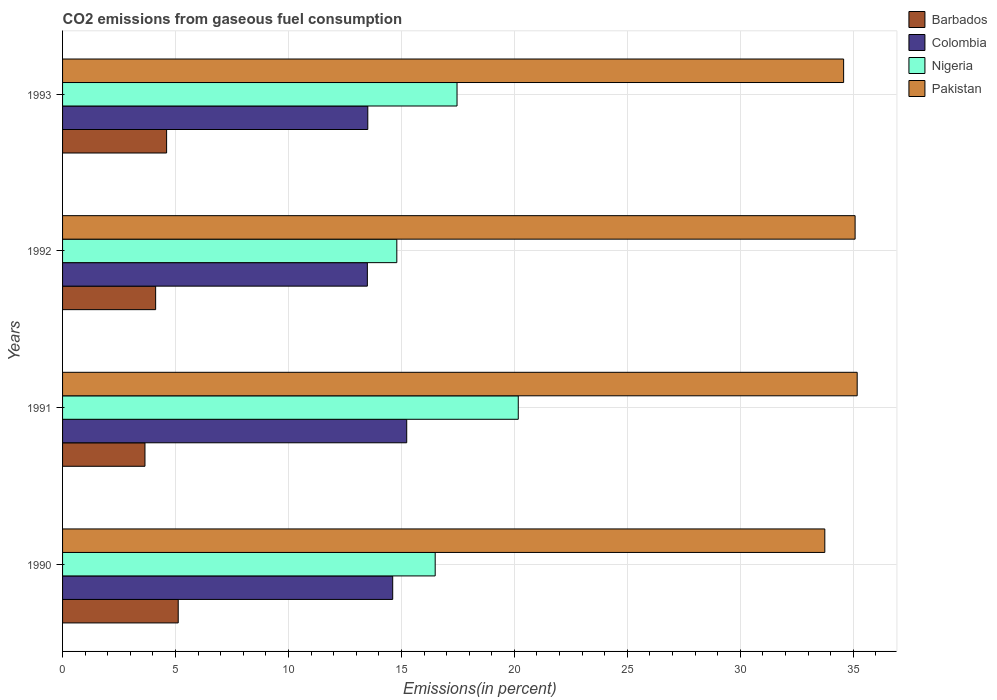How many groups of bars are there?
Your answer should be very brief. 4. What is the label of the 2nd group of bars from the top?
Offer a very short reply. 1992. In how many cases, is the number of bars for a given year not equal to the number of legend labels?
Ensure brevity in your answer.  0. What is the total CO2 emitted in Nigeria in 1992?
Your response must be concise. 14.8. Across all years, what is the maximum total CO2 emitted in Barbados?
Your answer should be very brief. 5.12. Across all years, what is the minimum total CO2 emitted in Pakistan?
Your answer should be compact. 33.74. In which year was the total CO2 emitted in Colombia maximum?
Your answer should be very brief. 1991. In which year was the total CO2 emitted in Barbados minimum?
Provide a short and direct response. 1991. What is the total total CO2 emitted in Colombia in the graph?
Offer a very short reply. 56.85. What is the difference between the total CO2 emitted in Colombia in 1990 and that in 1993?
Your response must be concise. 1.1. What is the difference between the total CO2 emitted in Pakistan in 1993 and the total CO2 emitted in Barbados in 1992?
Your answer should be compact. 30.45. What is the average total CO2 emitted in Barbados per year?
Your answer should be very brief. 4.37. In the year 1992, what is the difference between the total CO2 emitted in Colombia and total CO2 emitted in Pakistan?
Give a very brief answer. -21.59. In how many years, is the total CO2 emitted in Pakistan greater than 28 %?
Provide a succinct answer. 4. What is the ratio of the total CO2 emitted in Colombia in 1990 to that in 1992?
Your answer should be compact. 1.08. Is the difference between the total CO2 emitted in Colombia in 1990 and 1992 greater than the difference between the total CO2 emitted in Pakistan in 1990 and 1992?
Your answer should be very brief. Yes. What is the difference between the highest and the second highest total CO2 emitted in Barbados?
Offer a terse response. 0.51. What is the difference between the highest and the lowest total CO2 emitted in Pakistan?
Provide a succinct answer. 1.43. In how many years, is the total CO2 emitted in Pakistan greater than the average total CO2 emitted in Pakistan taken over all years?
Keep it short and to the point. 2. What does the 2nd bar from the top in 1991 represents?
Your answer should be compact. Nigeria. Is it the case that in every year, the sum of the total CO2 emitted in Pakistan and total CO2 emitted in Colombia is greater than the total CO2 emitted in Nigeria?
Offer a very short reply. Yes. How many bars are there?
Your answer should be very brief. 16. Are all the bars in the graph horizontal?
Your answer should be compact. Yes. What is the difference between two consecutive major ticks on the X-axis?
Offer a very short reply. 5. Does the graph contain any zero values?
Give a very brief answer. No. Does the graph contain grids?
Offer a terse response. Yes. How many legend labels are there?
Offer a very short reply. 4. What is the title of the graph?
Offer a terse response. CO2 emissions from gaseous fuel consumption. Does "Liechtenstein" appear as one of the legend labels in the graph?
Keep it short and to the point. No. What is the label or title of the X-axis?
Give a very brief answer. Emissions(in percent). What is the label or title of the Y-axis?
Ensure brevity in your answer.  Years. What is the Emissions(in percent) in Barbados in 1990?
Provide a succinct answer. 5.12. What is the Emissions(in percent) in Colombia in 1990?
Make the answer very short. 14.61. What is the Emissions(in percent) in Nigeria in 1990?
Offer a very short reply. 16.49. What is the Emissions(in percent) of Pakistan in 1990?
Provide a succinct answer. 33.74. What is the Emissions(in percent) of Barbados in 1991?
Offer a terse response. 3.65. What is the Emissions(in percent) in Colombia in 1991?
Provide a succinct answer. 15.23. What is the Emissions(in percent) in Nigeria in 1991?
Keep it short and to the point. 20.17. What is the Emissions(in percent) of Pakistan in 1991?
Offer a very short reply. 35.17. What is the Emissions(in percent) of Barbados in 1992?
Keep it short and to the point. 4.12. What is the Emissions(in percent) in Colombia in 1992?
Keep it short and to the point. 13.49. What is the Emissions(in percent) in Nigeria in 1992?
Give a very brief answer. 14.8. What is the Emissions(in percent) in Pakistan in 1992?
Ensure brevity in your answer.  35.08. What is the Emissions(in percent) of Barbados in 1993?
Provide a short and direct response. 4.61. What is the Emissions(in percent) of Colombia in 1993?
Make the answer very short. 13.51. What is the Emissions(in percent) in Nigeria in 1993?
Offer a terse response. 17.46. What is the Emissions(in percent) in Pakistan in 1993?
Provide a succinct answer. 34.57. Across all years, what is the maximum Emissions(in percent) in Barbados?
Ensure brevity in your answer.  5.12. Across all years, what is the maximum Emissions(in percent) in Colombia?
Your answer should be very brief. 15.23. Across all years, what is the maximum Emissions(in percent) of Nigeria?
Offer a terse response. 20.17. Across all years, what is the maximum Emissions(in percent) of Pakistan?
Provide a succinct answer. 35.17. Across all years, what is the minimum Emissions(in percent) of Barbados?
Give a very brief answer. 3.65. Across all years, what is the minimum Emissions(in percent) in Colombia?
Keep it short and to the point. 13.49. Across all years, what is the minimum Emissions(in percent) in Nigeria?
Ensure brevity in your answer.  14.8. Across all years, what is the minimum Emissions(in percent) in Pakistan?
Make the answer very short. 33.74. What is the total Emissions(in percent) of Barbados in the graph?
Ensure brevity in your answer.  17.49. What is the total Emissions(in percent) in Colombia in the graph?
Your answer should be compact. 56.85. What is the total Emissions(in percent) of Nigeria in the graph?
Your response must be concise. 68.92. What is the total Emissions(in percent) of Pakistan in the graph?
Offer a terse response. 138.57. What is the difference between the Emissions(in percent) in Barbados in 1990 and that in 1991?
Provide a short and direct response. 1.47. What is the difference between the Emissions(in percent) of Colombia in 1990 and that in 1991?
Give a very brief answer. -0.62. What is the difference between the Emissions(in percent) in Nigeria in 1990 and that in 1991?
Your answer should be very brief. -3.68. What is the difference between the Emissions(in percent) of Pakistan in 1990 and that in 1991?
Ensure brevity in your answer.  -1.43. What is the difference between the Emissions(in percent) of Barbados in 1990 and that in 1992?
Offer a very short reply. 1. What is the difference between the Emissions(in percent) of Colombia in 1990 and that in 1992?
Your answer should be very brief. 1.12. What is the difference between the Emissions(in percent) of Nigeria in 1990 and that in 1992?
Offer a very short reply. 1.7. What is the difference between the Emissions(in percent) of Pakistan in 1990 and that in 1992?
Provide a short and direct response. -1.34. What is the difference between the Emissions(in percent) in Barbados in 1990 and that in 1993?
Make the answer very short. 0.51. What is the difference between the Emissions(in percent) in Colombia in 1990 and that in 1993?
Offer a very short reply. 1.1. What is the difference between the Emissions(in percent) of Nigeria in 1990 and that in 1993?
Ensure brevity in your answer.  -0.97. What is the difference between the Emissions(in percent) in Pakistan in 1990 and that in 1993?
Keep it short and to the point. -0.83. What is the difference between the Emissions(in percent) in Barbados in 1991 and that in 1992?
Give a very brief answer. -0.47. What is the difference between the Emissions(in percent) in Colombia in 1991 and that in 1992?
Give a very brief answer. 1.74. What is the difference between the Emissions(in percent) of Nigeria in 1991 and that in 1992?
Your response must be concise. 5.38. What is the difference between the Emissions(in percent) of Pakistan in 1991 and that in 1992?
Offer a very short reply. 0.09. What is the difference between the Emissions(in percent) of Barbados in 1991 and that in 1993?
Your answer should be very brief. -0.96. What is the difference between the Emissions(in percent) of Colombia in 1991 and that in 1993?
Provide a succinct answer. 1.72. What is the difference between the Emissions(in percent) of Nigeria in 1991 and that in 1993?
Offer a very short reply. 2.71. What is the difference between the Emissions(in percent) in Pakistan in 1991 and that in 1993?
Offer a very short reply. 0.6. What is the difference between the Emissions(in percent) in Barbados in 1992 and that in 1993?
Your answer should be compact. -0.49. What is the difference between the Emissions(in percent) of Colombia in 1992 and that in 1993?
Keep it short and to the point. -0.02. What is the difference between the Emissions(in percent) of Nigeria in 1992 and that in 1993?
Offer a terse response. -2.67. What is the difference between the Emissions(in percent) of Pakistan in 1992 and that in 1993?
Ensure brevity in your answer.  0.51. What is the difference between the Emissions(in percent) in Barbados in 1990 and the Emissions(in percent) in Colombia in 1991?
Provide a short and direct response. -10.11. What is the difference between the Emissions(in percent) of Barbados in 1990 and the Emissions(in percent) of Nigeria in 1991?
Ensure brevity in your answer.  -15.05. What is the difference between the Emissions(in percent) in Barbados in 1990 and the Emissions(in percent) in Pakistan in 1991?
Your answer should be compact. -30.06. What is the difference between the Emissions(in percent) of Colombia in 1990 and the Emissions(in percent) of Nigeria in 1991?
Give a very brief answer. -5.56. What is the difference between the Emissions(in percent) of Colombia in 1990 and the Emissions(in percent) of Pakistan in 1991?
Offer a very short reply. -20.56. What is the difference between the Emissions(in percent) in Nigeria in 1990 and the Emissions(in percent) in Pakistan in 1991?
Your response must be concise. -18.68. What is the difference between the Emissions(in percent) of Barbados in 1990 and the Emissions(in percent) of Colombia in 1992?
Give a very brief answer. -8.37. What is the difference between the Emissions(in percent) of Barbados in 1990 and the Emissions(in percent) of Nigeria in 1992?
Your response must be concise. -9.68. What is the difference between the Emissions(in percent) of Barbados in 1990 and the Emissions(in percent) of Pakistan in 1992?
Your response must be concise. -29.96. What is the difference between the Emissions(in percent) in Colombia in 1990 and the Emissions(in percent) in Nigeria in 1992?
Offer a terse response. -0.18. What is the difference between the Emissions(in percent) in Colombia in 1990 and the Emissions(in percent) in Pakistan in 1992?
Provide a succinct answer. -20.47. What is the difference between the Emissions(in percent) in Nigeria in 1990 and the Emissions(in percent) in Pakistan in 1992?
Your answer should be very brief. -18.59. What is the difference between the Emissions(in percent) of Barbados in 1990 and the Emissions(in percent) of Colombia in 1993?
Keep it short and to the point. -8.39. What is the difference between the Emissions(in percent) of Barbados in 1990 and the Emissions(in percent) of Nigeria in 1993?
Provide a succinct answer. -12.34. What is the difference between the Emissions(in percent) of Barbados in 1990 and the Emissions(in percent) of Pakistan in 1993?
Your response must be concise. -29.45. What is the difference between the Emissions(in percent) of Colombia in 1990 and the Emissions(in percent) of Nigeria in 1993?
Your answer should be compact. -2.85. What is the difference between the Emissions(in percent) in Colombia in 1990 and the Emissions(in percent) in Pakistan in 1993?
Provide a short and direct response. -19.96. What is the difference between the Emissions(in percent) in Nigeria in 1990 and the Emissions(in percent) in Pakistan in 1993?
Your answer should be compact. -18.08. What is the difference between the Emissions(in percent) of Barbados in 1991 and the Emissions(in percent) of Colombia in 1992?
Make the answer very short. -9.84. What is the difference between the Emissions(in percent) in Barbados in 1991 and the Emissions(in percent) in Nigeria in 1992?
Offer a very short reply. -11.15. What is the difference between the Emissions(in percent) of Barbados in 1991 and the Emissions(in percent) of Pakistan in 1992?
Your answer should be compact. -31.44. What is the difference between the Emissions(in percent) of Colombia in 1991 and the Emissions(in percent) of Nigeria in 1992?
Your answer should be very brief. 0.44. What is the difference between the Emissions(in percent) of Colombia in 1991 and the Emissions(in percent) of Pakistan in 1992?
Provide a short and direct response. -19.85. What is the difference between the Emissions(in percent) of Nigeria in 1991 and the Emissions(in percent) of Pakistan in 1992?
Your answer should be compact. -14.91. What is the difference between the Emissions(in percent) of Barbados in 1991 and the Emissions(in percent) of Colombia in 1993?
Give a very brief answer. -9.86. What is the difference between the Emissions(in percent) in Barbados in 1991 and the Emissions(in percent) in Nigeria in 1993?
Offer a very short reply. -13.81. What is the difference between the Emissions(in percent) of Barbados in 1991 and the Emissions(in percent) of Pakistan in 1993?
Ensure brevity in your answer.  -30.93. What is the difference between the Emissions(in percent) of Colombia in 1991 and the Emissions(in percent) of Nigeria in 1993?
Provide a succinct answer. -2.23. What is the difference between the Emissions(in percent) of Colombia in 1991 and the Emissions(in percent) of Pakistan in 1993?
Offer a very short reply. -19.34. What is the difference between the Emissions(in percent) in Nigeria in 1991 and the Emissions(in percent) in Pakistan in 1993?
Your answer should be compact. -14.4. What is the difference between the Emissions(in percent) in Barbados in 1992 and the Emissions(in percent) in Colombia in 1993?
Make the answer very short. -9.39. What is the difference between the Emissions(in percent) of Barbados in 1992 and the Emissions(in percent) of Nigeria in 1993?
Your response must be concise. -13.34. What is the difference between the Emissions(in percent) of Barbados in 1992 and the Emissions(in percent) of Pakistan in 1993?
Keep it short and to the point. -30.45. What is the difference between the Emissions(in percent) in Colombia in 1992 and the Emissions(in percent) in Nigeria in 1993?
Make the answer very short. -3.97. What is the difference between the Emissions(in percent) of Colombia in 1992 and the Emissions(in percent) of Pakistan in 1993?
Make the answer very short. -21.08. What is the difference between the Emissions(in percent) of Nigeria in 1992 and the Emissions(in percent) of Pakistan in 1993?
Keep it short and to the point. -19.78. What is the average Emissions(in percent) of Barbados per year?
Provide a succinct answer. 4.37. What is the average Emissions(in percent) in Colombia per year?
Your answer should be very brief. 14.21. What is the average Emissions(in percent) of Nigeria per year?
Provide a short and direct response. 17.23. What is the average Emissions(in percent) in Pakistan per year?
Your answer should be compact. 34.64. In the year 1990, what is the difference between the Emissions(in percent) in Barbados and Emissions(in percent) in Colombia?
Keep it short and to the point. -9.49. In the year 1990, what is the difference between the Emissions(in percent) of Barbados and Emissions(in percent) of Nigeria?
Your response must be concise. -11.37. In the year 1990, what is the difference between the Emissions(in percent) of Barbados and Emissions(in percent) of Pakistan?
Provide a succinct answer. -28.62. In the year 1990, what is the difference between the Emissions(in percent) in Colombia and Emissions(in percent) in Nigeria?
Offer a terse response. -1.88. In the year 1990, what is the difference between the Emissions(in percent) of Colombia and Emissions(in percent) of Pakistan?
Your answer should be compact. -19.13. In the year 1990, what is the difference between the Emissions(in percent) of Nigeria and Emissions(in percent) of Pakistan?
Provide a succinct answer. -17.25. In the year 1991, what is the difference between the Emissions(in percent) in Barbados and Emissions(in percent) in Colombia?
Make the answer very short. -11.59. In the year 1991, what is the difference between the Emissions(in percent) in Barbados and Emissions(in percent) in Nigeria?
Provide a short and direct response. -16.52. In the year 1991, what is the difference between the Emissions(in percent) in Barbados and Emissions(in percent) in Pakistan?
Offer a terse response. -31.53. In the year 1991, what is the difference between the Emissions(in percent) in Colombia and Emissions(in percent) in Nigeria?
Your answer should be compact. -4.94. In the year 1991, what is the difference between the Emissions(in percent) in Colombia and Emissions(in percent) in Pakistan?
Your answer should be compact. -19.94. In the year 1991, what is the difference between the Emissions(in percent) in Nigeria and Emissions(in percent) in Pakistan?
Provide a short and direct response. -15. In the year 1992, what is the difference between the Emissions(in percent) of Barbados and Emissions(in percent) of Colombia?
Provide a succinct answer. -9.37. In the year 1992, what is the difference between the Emissions(in percent) in Barbados and Emissions(in percent) in Nigeria?
Ensure brevity in your answer.  -10.68. In the year 1992, what is the difference between the Emissions(in percent) in Barbados and Emissions(in percent) in Pakistan?
Ensure brevity in your answer.  -30.96. In the year 1992, what is the difference between the Emissions(in percent) of Colombia and Emissions(in percent) of Nigeria?
Provide a succinct answer. -1.3. In the year 1992, what is the difference between the Emissions(in percent) in Colombia and Emissions(in percent) in Pakistan?
Provide a short and direct response. -21.59. In the year 1992, what is the difference between the Emissions(in percent) in Nigeria and Emissions(in percent) in Pakistan?
Your response must be concise. -20.29. In the year 1993, what is the difference between the Emissions(in percent) in Barbados and Emissions(in percent) in Colombia?
Your answer should be compact. -8.91. In the year 1993, what is the difference between the Emissions(in percent) of Barbados and Emissions(in percent) of Nigeria?
Ensure brevity in your answer.  -12.86. In the year 1993, what is the difference between the Emissions(in percent) in Barbados and Emissions(in percent) in Pakistan?
Make the answer very short. -29.97. In the year 1993, what is the difference between the Emissions(in percent) in Colombia and Emissions(in percent) in Nigeria?
Provide a succinct answer. -3.95. In the year 1993, what is the difference between the Emissions(in percent) in Colombia and Emissions(in percent) in Pakistan?
Your response must be concise. -21.06. In the year 1993, what is the difference between the Emissions(in percent) in Nigeria and Emissions(in percent) in Pakistan?
Ensure brevity in your answer.  -17.11. What is the ratio of the Emissions(in percent) of Barbados in 1990 to that in 1991?
Ensure brevity in your answer.  1.4. What is the ratio of the Emissions(in percent) in Colombia in 1990 to that in 1991?
Ensure brevity in your answer.  0.96. What is the ratio of the Emissions(in percent) of Nigeria in 1990 to that in 1991?
Keep it short and to the point. 0.82. What is the ratio of the Emissions(in percent) of Pakistan in 1990 to that in 1991?
Make the answer very short. 0.96. What is the ratio of the Emissions(in percent) in Barbados in 1990 to that in 1992?
Keep it short and to the point. 1.24. What is the ratio of the Emissions(in percent) of Colombia in 1990 to that in 1992?
Offer a very short reply. 1.08. What is the ratio of the Emissions(in percent) of Nigeria in 1990 to that in 1992?
Ensure brevity in your answer.  1.11. What is the ratio of the Emissions(in percent) of Pakistan in 1990 to that in 1992?
Keep it short and to the point. 0.96. What is the ratio of the Emissions(in percent) in Barbados in 1990 to that in 1993?
Offer a terse response. 1.11. What is the ratio of the Emissions(in percent) of Colombia in 1990 to that in 1993?
Your answer should be compact. 1.08. What is the ratio of the Emissions(in percent) in Nigeria in 1990 to that in 1993?
Give a very brief answer. 0.94. What is the ratio of the Emissions(in percent) in Pakistan in 1990 to that in 1993?
Ensure brevity in your answer.  0.98. What is the ratio of the Emissions(in percent) in Barbados in 1991 to that in 1992?
Provide a succinct answer. 0.89. What is the ratio of the Emissions(in percent) of Colombia in 1991 to that in 1992?
Give a very brief answer. 1.13. What is the ratio of the Emissions(in percent) of Nigeria in 1991 to that in 1992?
Offer a terse response. 1.36. What is the ratio of the Emissions(in percent) of Pakistan in 1991 to that in 1992?
Your answer should be very brief. 1. What is the ratio of the Emissions(in percent) of Barbados in 1991 to that in 1993?
Make the answer very short. 0.79. What is the ratio of the Emissions(in percent) in Colombia in 1991 to that in 1993?
Ensure brevity in your answer.  1.13. What is the ratio of the Emissions(in percent) of Nigeria in 1991 to that in 1993?
Your answer should be compact. 1.16. What is the ratio of the Emissions(in percent) in Pakistan in 1991 to that in 1993?
Your answer should be very brief. 1.02. What is the ratio of the Emissions(in percent) in Barbados in 1992 to that in 1993?
Offer a terse response. 0.89. What is the ratio of the Emissions(in percent) of Nigeria in 1992 to that in 1993?
Your answer should be compact. 0.85. What is the ratio of the Emissions(in percent) of Pakistan in 1992 to that in 1993?
Offer a terse response. 1.01. What is the difference between the highest and the second highest Emissions(in percent) in Barbados?
Provide a short and direct response. 0.51. What is the difference between the highest and the second highest Emissions(in percent) in Colombia?
Your response must be concise. 0.62. What is the difference between the highest and the second highest Emissions(in percent) of Nigeria?
Give a very brief answer. 2.71. What is the difference between the highest and the second highest Emissions(in percent) of Pakistan?
Ensure brevity in your answer.  0.09. What is the difference between the highest and the lowest Emissions(in percent) of Barbados?
Offer a terse response. 1.47. What is the difference between the highest and the lowest Emissions(in percent) in Colombia?
Your answer should be very brief. 1.74. What is the difference between the highest and the lowest Emissions(in percent) in Nigeria?
Your answer should be compact. 5.38. What is the difference between the highest and the lowest Emissions(in percent) of Pakistan?
Provide a short and direct response. 1.43. 